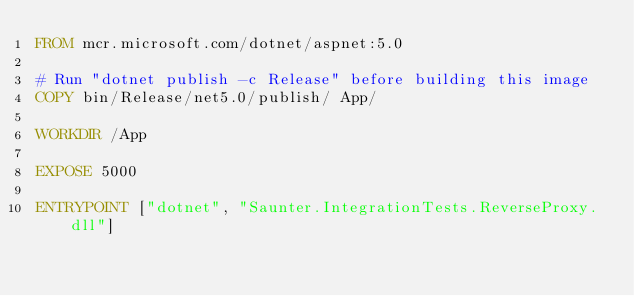<code> <loc_0><loc_0><loc_500><loc_500><_Dockerfile_>FROM mcr.microsoft.com/dotnet/aspnet:5.0

# Run "dotnet publish -c Release" before building this image
COPY bin/Release/net5.0/publish/ App/

WORKDIR /App

EXPOSE 5000

ENTRYPOINT ["dotnet", "Saunter.IntegrationTests.ReverseProxy.dll"]
</code> 